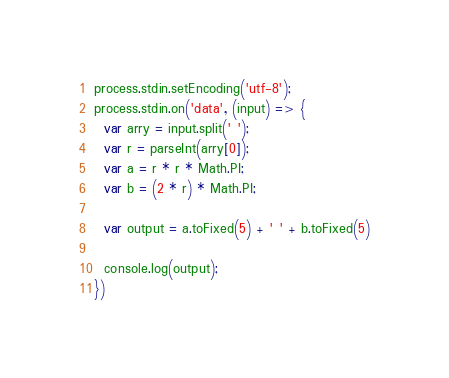Convert code to text. <code><loc_0><loc_0><loc_500><loc_500><_JavaScript_>process.stdin.setEncoding('utf-8');
process.stdin.on('data', (input) => {
  var arry = input.split(' ');
  var r = parseInt(arry[0]);
  var a = r * r * Math.PI;
  var b = (2 * r) * Math.PI;

  var output = a.toFixed(5) + ' ' + b.toFixed(5)

  console.log(output);
})

</code> 